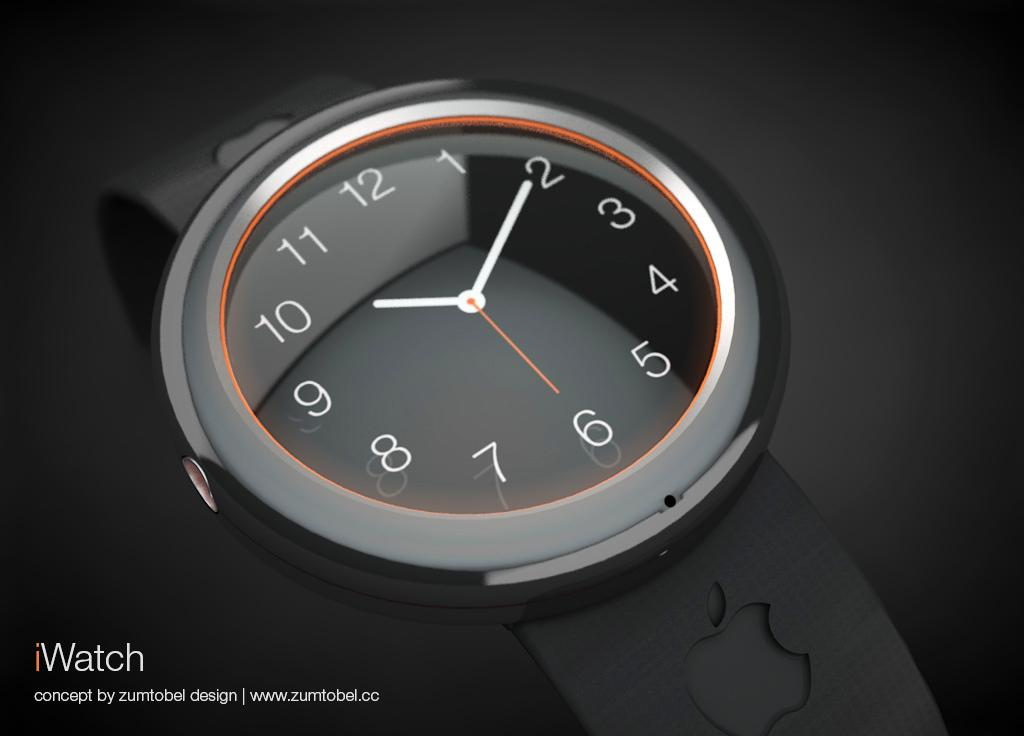<image>
Present a compact description of the photo's key features. In this image of an iWatch the time is 10:10. 